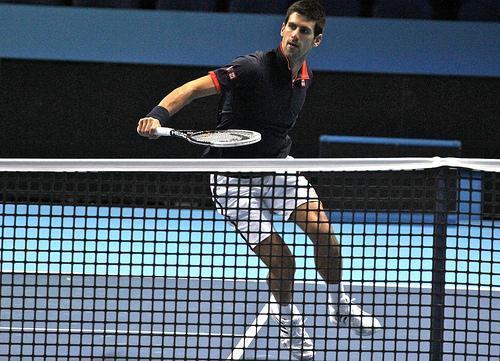How many people are shown?
Give a very brief answer. 1. 